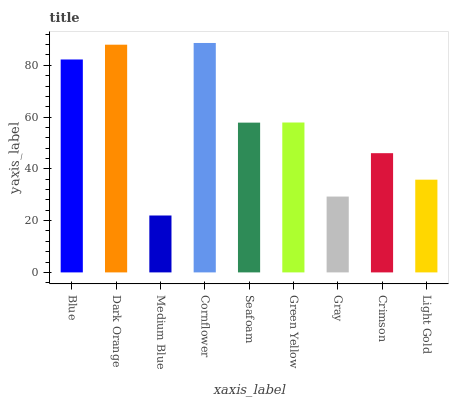Is Dark Orange the minimum?
Answer yes or no. No. Is Dark Orange the maximum?
Answer yes or no. No. Is Dark Orange greater than Blue?
Answer yes or no. Yes. Is Blue less than Dark Orange?
Answer yes or no. Yes. Is Blue greater than Dark Orange?
Answer yes or no. No. Is Dark Orange less than Blue?
Answer yes or no. No. Is Seafoam the high median?
Answer yes or no. Yes. Is Seafoam the low median?
Answer yes or no. Yes. Is Medium Blue the high median?
Answer yes or no. No. Is Blue the low median?
Answer yes or no. No. 